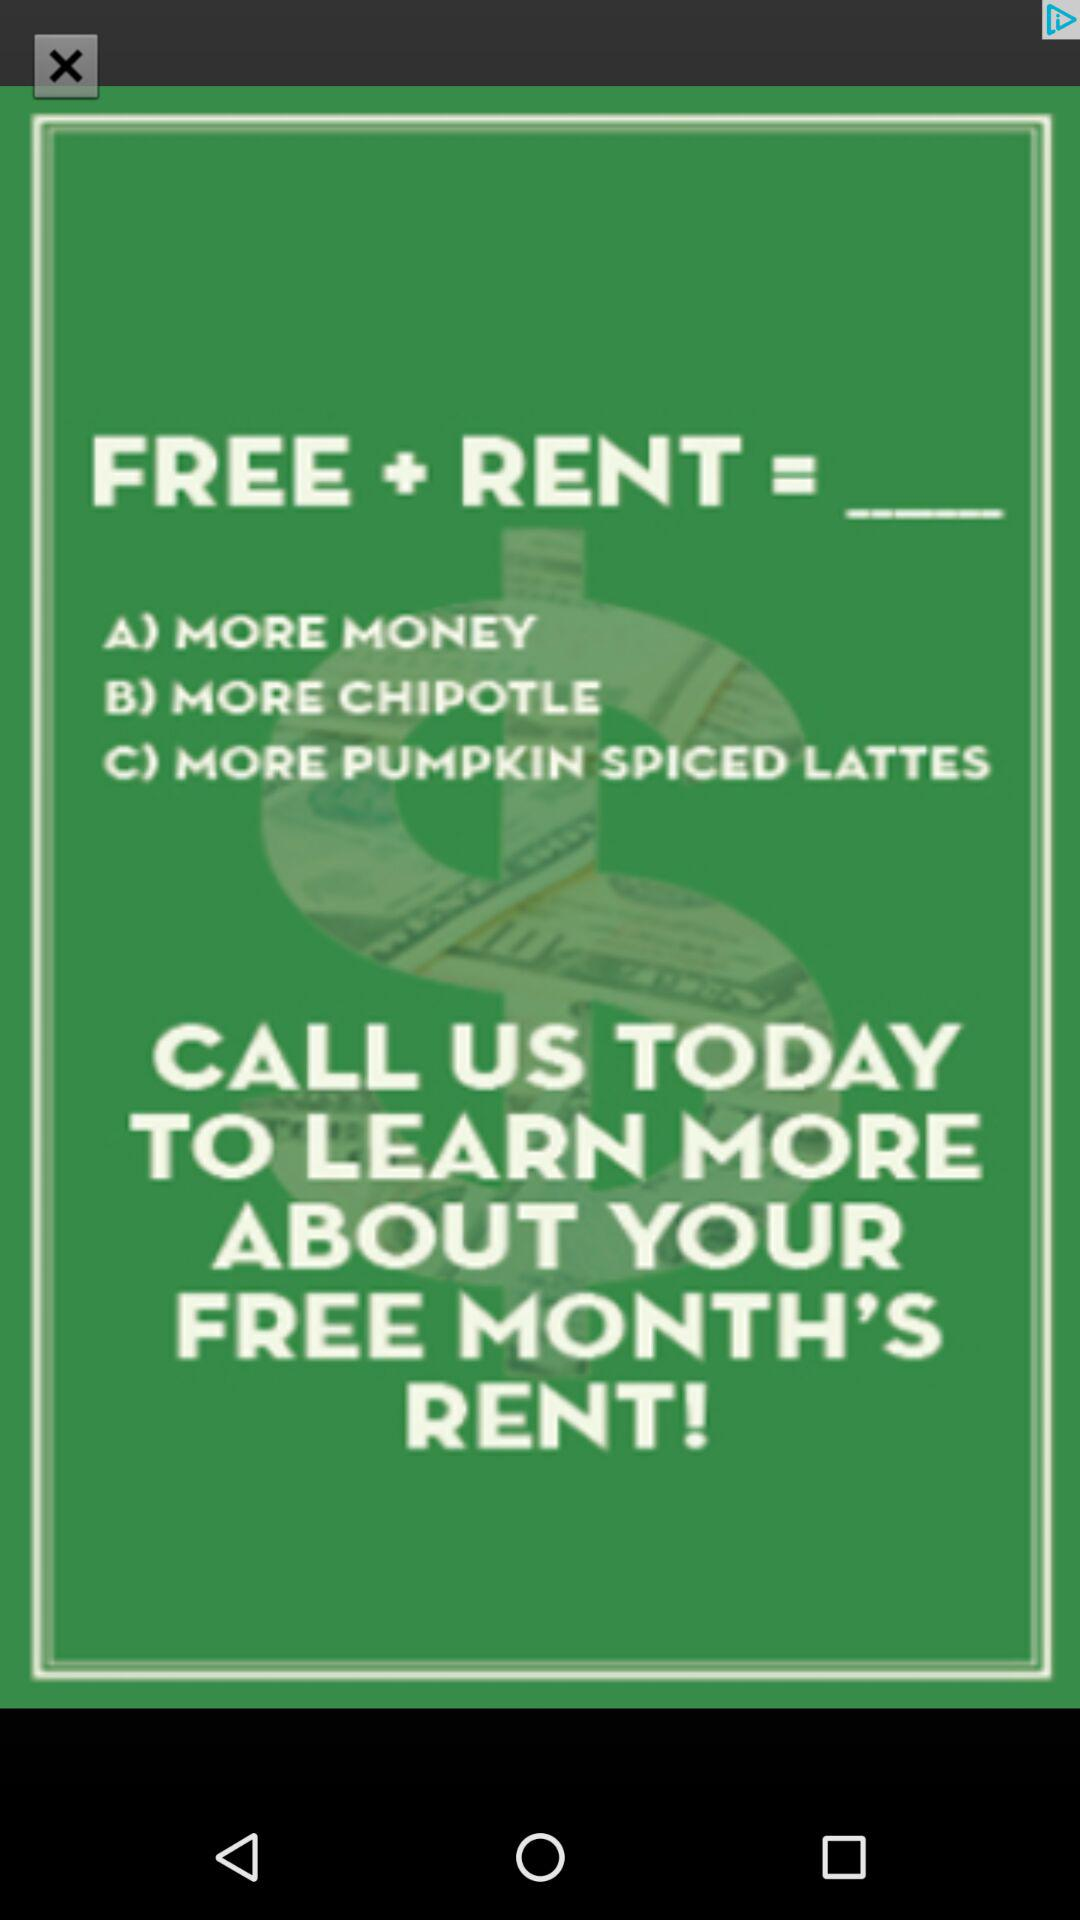How many options are there for free rent?
Answer the question using a single word or phrase. 3 